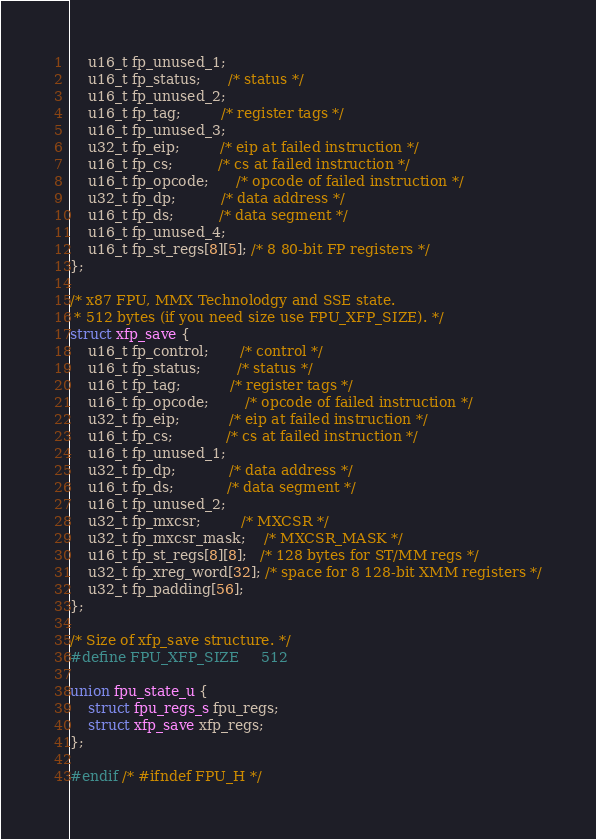Convert code to text. <code><loc_0><loc_0><loc_500><loc_500><_C_>	u16_t fp_unused_1;
	u16_t fp_status;      /* status */
	u16_t fp_unused_2;
	u16_t fp_tag;         /* register tags */
	u16_t fp_unused_3;
	u32_t fp_eip;         /* eip at failed instruction */
	u16_t fp_cs;          /* cs at failed instruction */
	u16_t fp_opcode;      /* opcode of failed instruction */
	u32_t fp_dp;          /* data address */
	u16_t fp_ds;          /* data segment */
	u16_t fp_unused_4;
	u16_t fp_st_regs[8][5]; /* 8 80-bit FP registers */
};

/* x87 FPU, MMX Technolodgy and SSE state.
 * 512 bytes (if you need size use FPU_XFP_SIZE). */
struct xfp_save {
	u16_t fp_control;       /* control */
	u16_t fp_status;        /* status */
	u16_t fp_tag;           /* register tags */
	u16_t fp_opcode;        /* opcode of failed instruction */
	u32_t fp_eip;           /* eip at failed instruction */
	u16_t fp_cs;            /* cs at failed instruction */
	u16_t fp_unused_1;
	u32_t fp_dp;            /* data address */
	u16_t fp_ds;            /* data segment */
	u16_t fp_unused_2;
	u32_t fp_mxcsr;         /* MXCSR */
	u32_t fp_mxcsr_mask;    /* MXCSR_MASK */
	u16_t fp_st_regs[8][8];   /* 128 bytes for ST/MM regs */
	u32_t fp_xreg_word[32]; /* space for 8 128-bit XMM registers */
	u32_t fp_padding[56];
};

/* Size of xfp_save structure. */
#define FPU_XFP_SIZE		512

union fpu_state_u {
	struct fpu_regs_s fpu_regs;
	struct xfp_save xfp_regs;
};

#endif /* #ifndef FPU_H */
</code> 